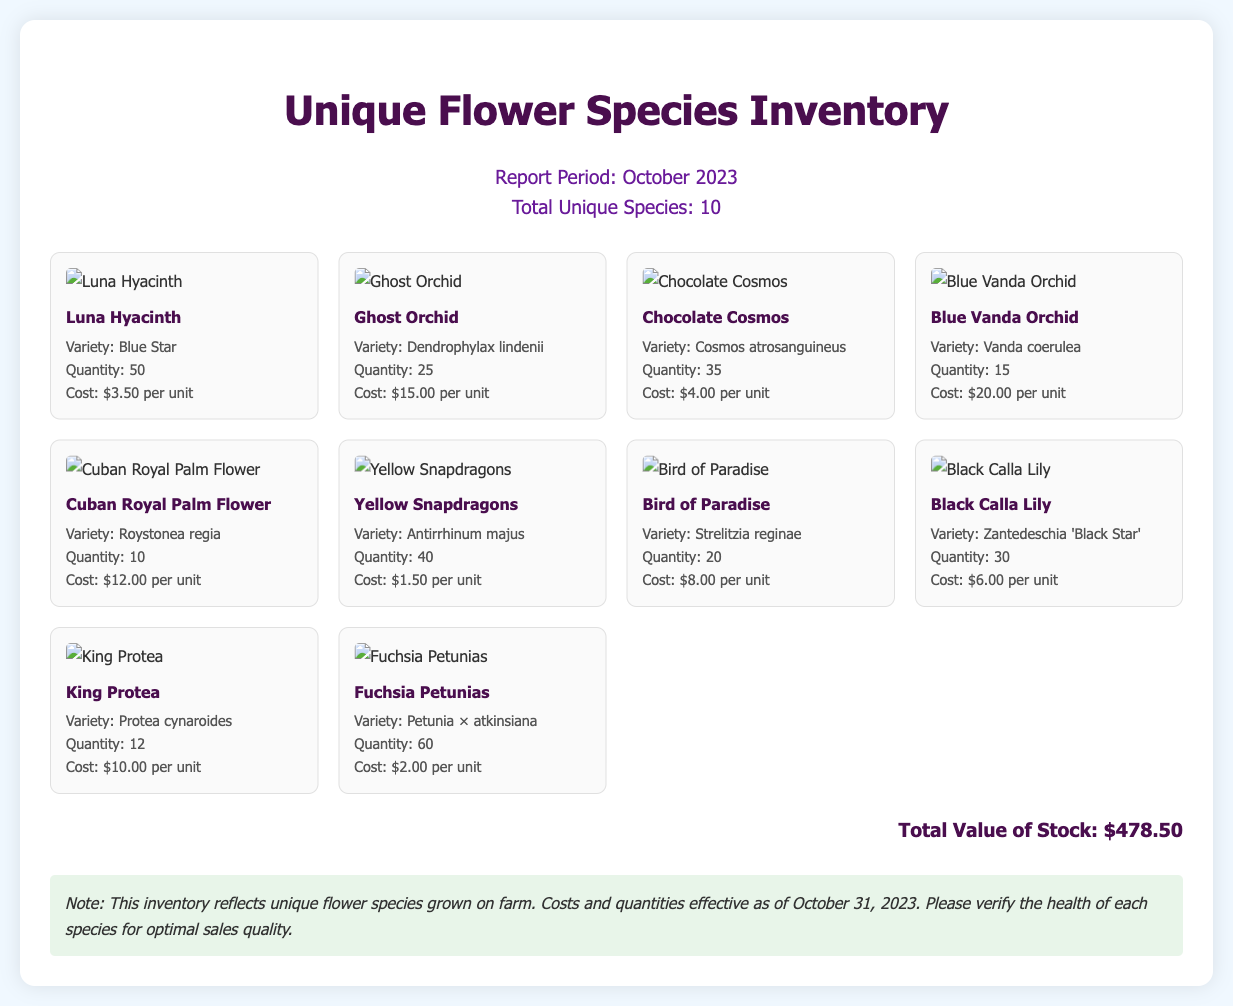What is the report period? The report period is stated at the top of the document, which is October 2023.
Answer: October 2023 How many unique species are listed? The total number of unique species is mentioned in the report info section.
Answer: 10 What is the quantity of Yellow Snapdragons? The quantity is specified in the flower card for Yellow Snapdragons.
Answer: 40 What is the cost of a Blue Vanda Orchid? The cost is provided in the details of the Blue Vanda Orchid flower card.
Answer: $20.00 per unit Which flower has the highest cost per unit? This requires comparing the costs listed for each flower; the highest is found to be the Ghost Orchid.
Answer: $15.00 per unit What is the total value of stock? This information is summarized at the end of the document.
Answer: $478.50 What variety does the Fuchsia Petunias belong to? The variety is detailed in the information section of the Fuchsia Petunias flower card.
Answer: Petunia × atkinsiana How many King Protea are in stock? The quantity is specified in the flower card for King Protea.
Answer: 12 Which flower species has the lowest quantity? This requires analyzing the quantities across all flower species; the Cuban Royal Palm Flower has the lowest.
Answer: 10 